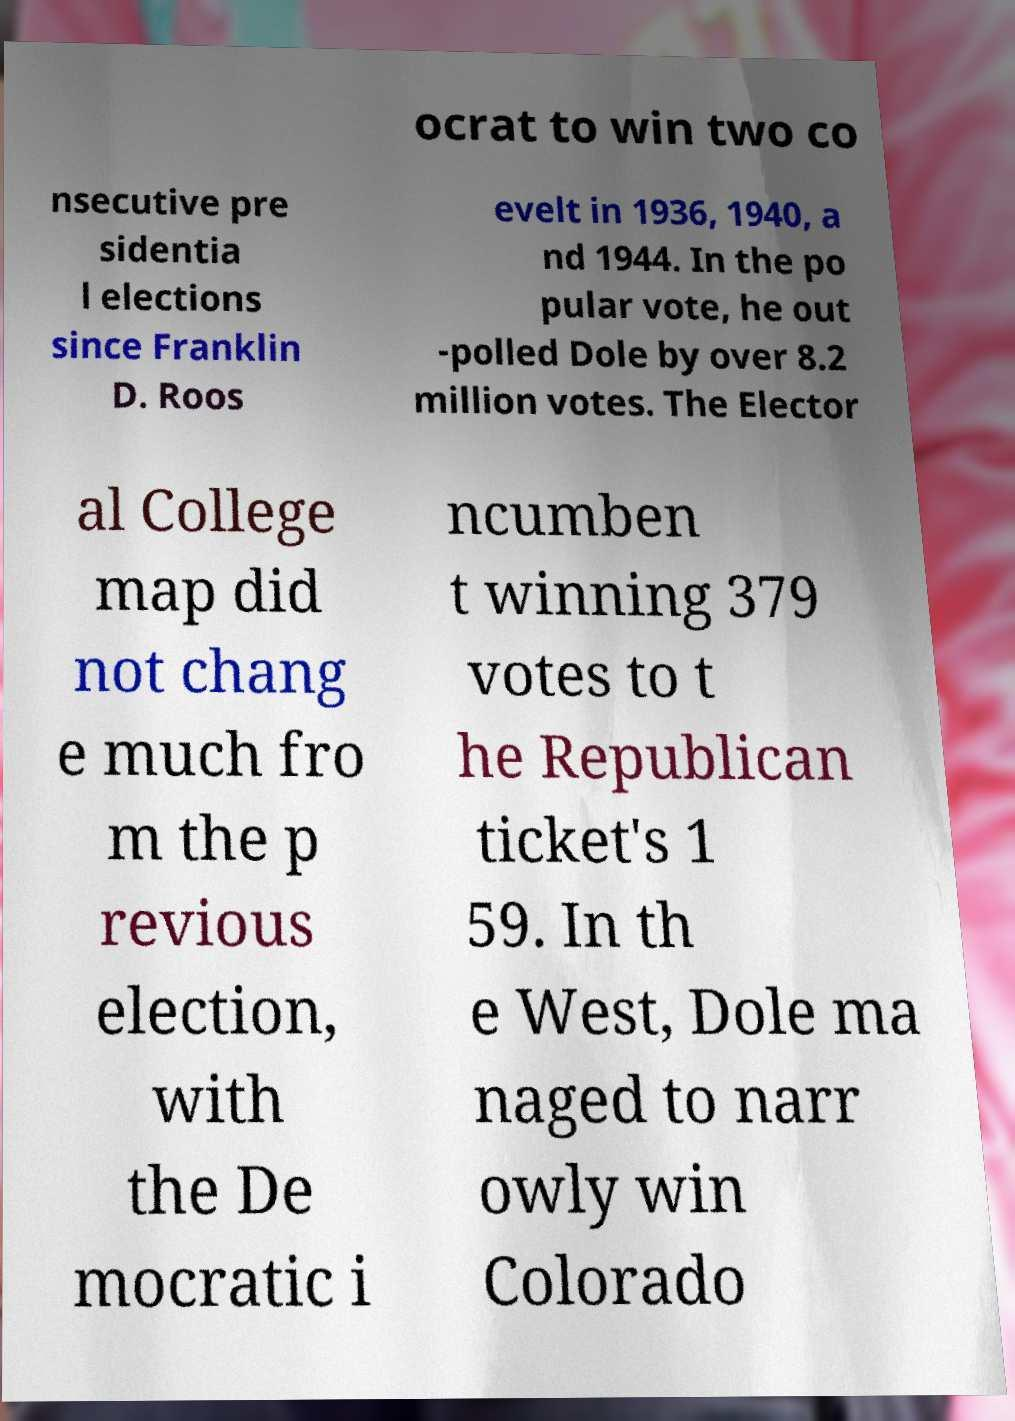I need the written content from this picture converted into text. Can you do that? ocrat to win two co nsecutive pre sidentia l elections since Franklin D. Roos evelt in 1936, 1940, a nd 1944. In the po pular vote, he out -polled Dole by over 8.2 million votes. The Elector al College map did not chang e much fro m the p revious election, with the De mocratic i ncumben t winning 379 votes to t he Republican ticket's 1 59. In th e West, Dole ma naged to narr owly win Colorado 